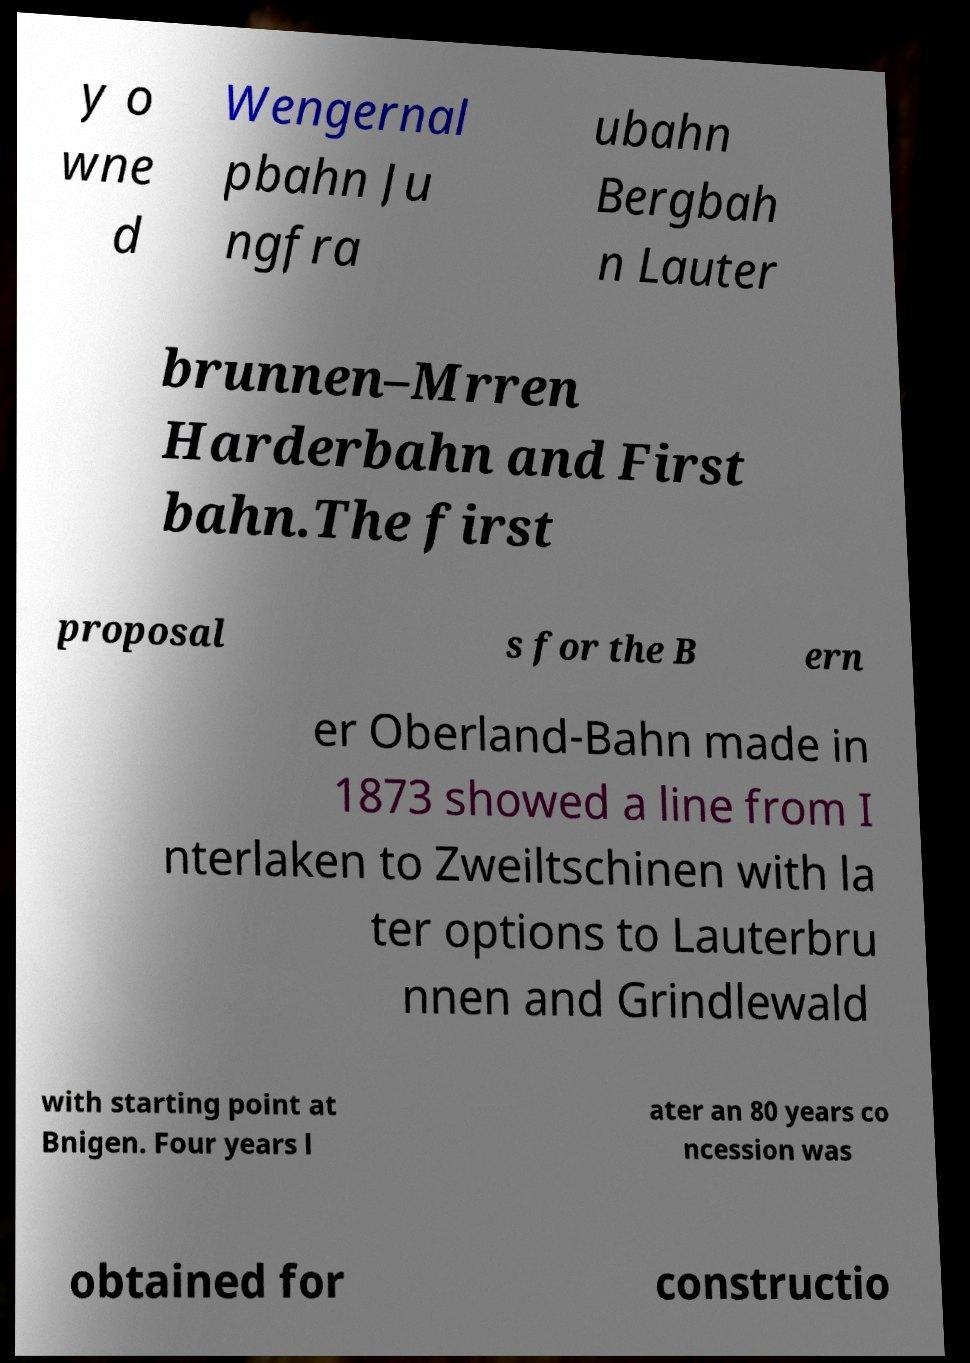Could you extract and type out the text from this image? y o wne d Wengernal pbahn Ju ngfra ubahn Bergbah n Lauter brunnen–Mrren Harderbahn and First bahn.The first proposal s for the B ern er Oberland-Bahn made in 1873 showed a line from I nterlaken to Zweiltschinen with la ter options to Lauterbru nnen and Grindlewald with starting point at Bnigen. Four years l ater an 80 years co ncession was obtained for constructio 